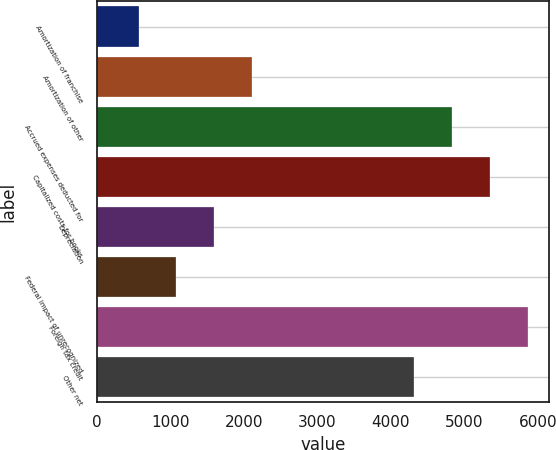Convert chart. <chart><loc_0><loc_0><loc_500><loc_500><bar_chart><fcel>Amortization of franchise<fcel>Amortization of other<fcel>Accrued expenses deducted for<fcel>Capitalized costs for books<fcel>Depreciation<fcel>Federal impact of unrecognized<fcel>Foreign tax credit<fcel>Other net<nl><fcel>570<fcel>2114.7<fcel>4828.9<fcel>5343.8<fcel>1599.8<fcel>1084.9<fcel>5858.7<fcel>4314<nl></chart> 